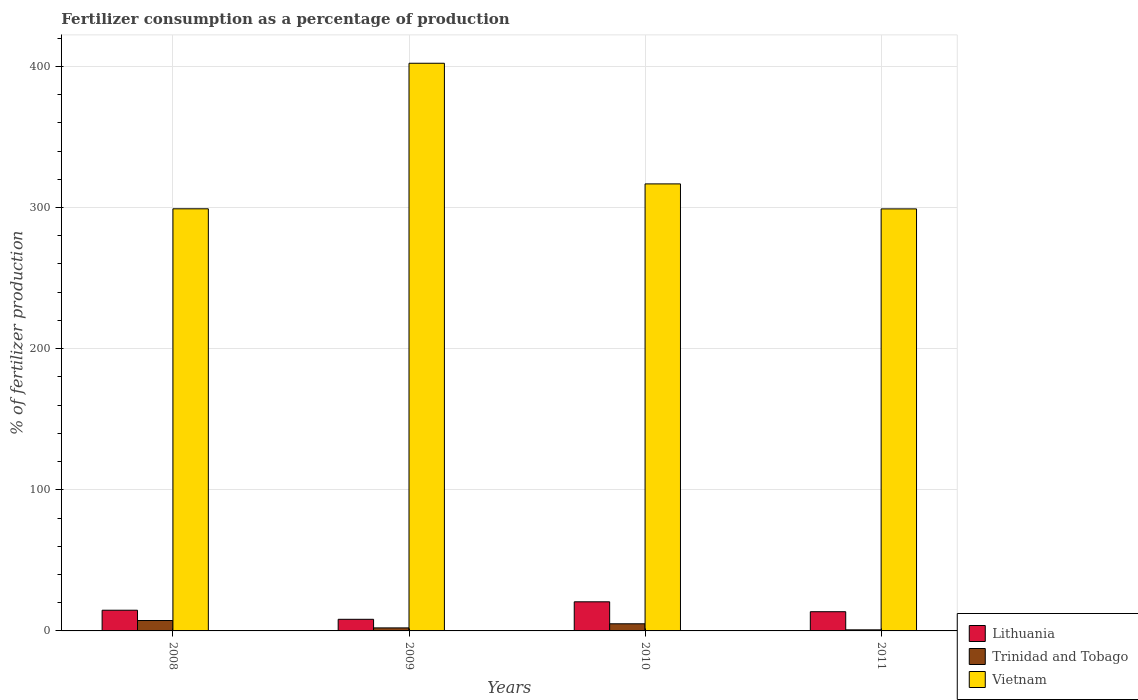How many groups of bars are there?
Offer a very short reply. 4. Are the number of bars per tick equal to the number of legend labels?
Offer a very short reply. Yes. How many bars are there on the 3rd tick from the right?
Your answer should be compact. 3. In how many cases, is the number of bars for a given year not equal to the number of legend labels?
Your response must be concise. 0. What is the percentage of fertilizers consumed in Vietnam in 2010?
Provide a succinct answer. 316.74. Across all years, what is the maximum percentage of fertilizers consumed in Lithuania?
Keep it short and to the point. 20.63. Across all years, what is the minimum percentage of fertilizers consumed in Trinidad and Tobago?
Your answer should be compact. 0.76. In which year was the percentage of fertilizers consumed in Trinidad and Tobago maximum?
Ensure brevity in your answer.  2008. In which year was the percentage of fertilizers consumed in Vietnam minimum?
Give a very brief answer. 2011. What is the total percentage of fertilizers consumed in Lithuania in the graph?
Offer a terse response. 57.13. What is the difference between the percentage of fertilizers consumed in Lithuania in 2008 and that in 2011?
Your response must be concise. 1.05. What is the difference between the percentage of fertilizers consumed in Vietnam in 2010 and the percentage of fertilizers consumed in Lithuania in 2009?
Your answer should be very brief. 308.5. What is the average percentage of fertilizers consumed in Lithuania per year?
Ensure brevity in your answer.  14.28. In the year 2010, what is the difference between the percentage of fertilizers consumed in Trinidad and Tobago and percentage of fertilizers consumed in Vietnam?
Provide a short and direct response. -311.68. What is the ratio of the percentage of fertilizers consumed in Trinidad and Tobago in 2010 to that in 2011?
Offer a very short reply. 6.65. What is the difference between the highest and the second highest percentage of fertilizers consumed in Vietnam?
Your answer should be compact. 85.48. What is the difference between the highest and the lowest percentage of fertilizers consumed in Vietnam?
Your answer should be compact. 103.2. What does the 2nd bar from the left in 2008 represents?
Ensure brevity in your answer.  Trinidad and Tobago. What does the 2nd bar from the right in 2009 represents?
Your answer should be compact. Trinidad and Tobago. Are all the bars in the graph horizontal?
Offer a very short reply. No. How many years are there in the graph?
Provide a succinct answer. 4. Does the graph contain grids?
Keep it short and to the point. Yes. Where does the legend appear in the graph?
Make the answer very short. Bottom right. How are the legend labels stacked?
Give a very brief answer. Vertical. What is the title of the graph?
Offer a very short reply. Fertilizer consumption as a percentage of production. What is the label or title of the X-axis?
Ensure brevity in your answer.  Years. What is the label or title of the Y-axis?
Give a very brief answer. % of fertilizer production. What is the % of fertilizer production in Lithuania in 2008?
Your answer should be compact. 14.66. What is the % of fertilizer production in Trinidad and Tobago in 2008?
Provide a short and direct response. 7.37. What is the % of fertilizer production in Vietnam in 2008?
Give a very brief answer. 299.09. What is the % of fertilizer production in Lithuania in 2009?
Give a very brief answer. 8.24. What is the % of fertilizer production in Trinidad and Tobago in 2009?
Your response must be concise. 2.14. What is the % of fertilizer production in Vietnam in 2009?
Ensure brevity in your answer.  402.22. What is the % of fertilizer production in Lithuania in 2010?
Make the answer very short. 20.63. What is the % of fertilizer production of Trinidad and Tobago in 2010?
Your response must be concise. 5.06. What is the % of fertilizer production of Vietnam in 2010?
Your answer should be very brief. 316.74. What is the % of fertilizer production in Lithuania in 2011?
Your answer should be compact. 13.61. What is the % of fertilizer production of Trinidad and Tobago in 2011?
Provide a succinct answer. 0.76. What is the % of fertilizer production in Vietnam in 2011?
Make the answer very short. 299.02. Across all years, what is the maximum % of fertilizer production of Lithuania?
Make the answer very short. 20.63. Across all years, what is the maximum % of fertilizer production of Trinidad and Tobago?
Your answer should be compact. 7.37. Across all years, what is the maximum % of fertilizer production in Vietnam?
Your answer should be very brief. 402.22. Across all years, what is the minimum % of fertilizer production of Lithuania?
Offer a very short reply. 8.24. Across all years, what is the minimum % of fertilizer production of Trinidad and Tobago?
Offer a very short reply. 0.76. Across all years, what is the minimum % of fertilizer production in Vietnam?
Make the answer very short. 299.02. What is the total % of fertilizer production in Lithuania in the graph?
Offer a terse response. 57.13. What is the total % of fertilizer production of Trinidad and Tobago in the graph?
Your answer should be compact. 15.33. What is the total % of fertilizer production in Vietnam in the graph?
Provide a succinct answer. 1317.06. What is the difference between the % of fertilizer production in Lithuania in 2008 and that in 2009?
Your answer should be very brief. 6.43. What is the difference between the % of fertilizer production of Trinidad and Tobago in 2008 and that in 2009?
Provide a succinct answer. 5.23. What is the difference between the % of fertilizer production of Vietnam in 2008 and that in 2009?
Provide a short and direct response. -103.13. What is the difference between the % of fertilizer production of Lithuania in 2008 and that in 2010?
Keep it short and to the point. -5.97. What is the difference between the % of fertilizer production in Trinidad and Tobago in 2008 and that in 2010?
Your answer should be very brief. 2.31. What is the difference between the % of fertilizer production in Vietnam in 2008 and that in 2010?
Offer a terse response. -17.65. What is the difference between the % of fertilizer production of Lithuania in 2008 and that in 2011?
Provide a succinct answer. 1.05. What is the difference between the % of fertilizer production of Trinidad and Tobago in 2008 and that in 2011?
Your answer should be compact. 6.61. What is the difference between the % of fertilizer production of Vietnam in 2008 and that in 2011?
Give a very brief answer. 0.07. What is the difference between the % of fertilizer production of Lithuania in 2009 and that in 2010?
Provide a short and direct response. -12.39. What is the difference between the % of fertilizer production of Trinidad and Tobago in 2009 and that in 2010?
Your answer should be compact. -2.91. What is the difference between the % of fertilizer production in Vietnam in 2009 and that in 2010?
Ensure brevity in your answer.  85.48. What is the difference between the % of fertilizer production of Lithuania in 2009 and that in 2011?
Provide a short and direct response. -5.37. What is the difference between the % of fertilizer production of Trinidad and Tobago in 2009 and that in 2011?
Offer a very short reply. 1.38. What is the difference between the % of fertilizer production in Vietnam in 2009 and that in 2011?
Give a very brief answer. 103.2. What is the difference between the % of fertilizer production of Lithuania in 2010 and that in 2011?
Offer a terse response. 7.02. What is the difference between the % of fertilizer production in Trinidad and Tobago in 2010 and that in 2011?
Provide a short and direct response. 4.3. What is the difference between the % of fertilizer production of Vietnam in 2010 and that in 2011?
Provide a succinct answer. 17.72. What is the difference between the % of fertilizer production in Lithuania in 2008 and the % of fertilizer production in Trinidad and Tobago in 2009?
Offer a terse response. 12.52. What is the difference between the % of fertilizer production in Lithuania in 2008 and the % of fertilizer production in Vietnam in 2009?
Offer a terse response. -387.55. What is the difference between the % of fertilizer production of Trinidad and Tobago in 2008 and the % of fertilizer production of Vietnam in 2009?
Offer a terse response. -394.84. What is the difference between the % of fertilizer production of Lithuania in 2008 and the % of fertilizer production of Trinidad and Tobago in 2010?
Ensure brevity in your answer.  9.6. What is the difference between the % of fertilizer production of Lithuania in 2008 and the % of fertilizer production of Vietnam in 2010?
Make the answer very short. -302.08. What is the difference between the % of fertilizer production of Trinidad and Tobago in 2008 and the % of fertilizer production of Vietnam in 2010?
Your answer should be compact. -309.37. What is the difference between the % of fertilizer production of Lithuania in 2008 and the % of fertilizer production of Trinidad and Tobago in 2011?
Your answer should be compact. 13.9. What is the difference between the % of fertilizer production of Lithuania in 2008 and the % of fertilizer production of Vietnam in 2011?
Your response must be concise. -284.36. What is the difference between the % of fertilizer production of Trinidad and Tobago in 2008 and the % of fertilizer production of Vietnam in 2011?
Keep it short and to the point. -291.65. What is the difference between the % of fertilizer production in Lithuania in 2009 and the % of fertilizer production in Trinidad and Tobago in 2010?
Your answer should be compact. 3.18. What is the difference between the % of fertilizer production in Lithuania in 2009 and the % of fertilizer production in Vietnam in 2010?
Provide a succinct answer. -308.5. What is the difference between the % of fertilizer production in Trinidad and Tobago in 2009 and the % of fertilizer production in Vietnam in 2010?
Make the answer very short. -314.59. What is the difference between the % of fertilizer production in Lithuania in 2009 and the % of fertilizer production in Trinidad and Tobago in 2011?
Provide a succinct answer. 7.47. What is the difference between the % of fertilizer production in Lithuania in 2009 and the % of fertilizer production in Vietnam in 2011?
Give a very brief answer. -290.78. What is the difference between the % of fertilizer production in Trinidad and Tobago in 2009 and the % of fertilizer production in Vietnam in 2011?
Ensure brevity in your answer.  -296.87. What is the difference between the % of fertilizer production of Lithuania in 2010 and the % of fertilizer production of Trinidad and Tobago in 2011?
Provide a short and direct response. 19.87. What is the difference between the % of fertilizer production of Lithuania in 2010 and the % of fertilizer production of Vietnam in 2011?
Offer a very short reply. -278.39. What is the difference between the % of fertilizer production in Trinidad and Tobago in 2010 and the % of fertilizer production in Vietnam in 2011?
Ensure brevity in your answer.  -293.96. What is the average % of fertilizer production of Lithuania per year?
Your answer should be compact. 14.28. What is the average % of fertilizer production of Trinidad and Tobago per year?
Provide a succinct answer. 3.83. What is the average % of fertilizer production of Vietnam per year?
Provide a short and direct response. 329.26. In the year 2008, what is the difference between the % of fertilizer production in Lithuania and % of fertilizer production in Trinidad and Tobago?
Offer a very short reply. 7.29. In the year 2008, what is the difference between the % of fertilizer production of Lithuania and % of fertilizer production of Vietnam?
Keep it short and to the point. -284.43. In the year 2008, what is the difference between the % of fertilizer production in Trinidad and Tobago and % of fertilizer production in Vietnam?
Your answer should be compact. -291.72. In the year 2009, what is the difference between the % of fertilizer production of Lithuania and % of fertilizer production of Trinidad and Tobago?
Ensure brevity in your answer.  6.09. In the year 2009, what is the difference between the % of fertilizer production in Lithuania and % of fertilizer production in Vietnam?
Your answer should be very brief. -393.98. In the year 2009, what is the difference between the % of fertilizer production of Trinidad and Tobago and % of fertilizer production of Vietnam?
Your answer should be compact. -400.07. In the year 2010, what is the difference between the % of fertilizer production in Lithuania and % of fertilizer production in Trinidad and Tobago?
Give a very brief answer. 15.57. In the year 2010, what is the difference between the % of fertilizer production of Lithuania and % of fertilizer production of Vietnam?
Make the answer very short. -296.11. In the year 2010, what is the difference between the % of fertilizer production of Trinidad and Tobago and % of fertilizer production of Vietnam?
Ensure brevity in your answer.  -311.68. In the year 2011, what is the difference between the % of fertilizer production of Lithuania and % of fertilizer production of Trinidad and Tobago?
Your answer should be compact. 12.85. In the year 2011, what is the difference between the % of fertilizer production in Lithuania and % of fertilizer production in Vietnam?
Offer a very short reply. -285.41. In the year 2011, what is the difference between the % of fertilizer production in Trinidad and Tobago and % of fertilizer production in Vietnam?
Your answer should be compact. -298.26. What is the ratio of the % of fertilizer production in Lithuania in 2008 to that in 2009?
Provide a succinct answer. 1.78. What is the ratio of the % of fertilizer production of Trinidad and Tobago in 2008 to that in 2009?
Offer a very short reply. 3.44. What is the ratio of the % of fertilizer production of Vietnam in 2008 to that in 2009?
Your response must be concise. 0.74. What is the ratio of the % of fertilizer production in Lithuania in 2008 to that in 2010?
Your response must be concise. 0.71. What is the ratio of the % of fertilizer production in Trinidad and Tobago in 2008 to that in 2010?
Your answer should be very brief. 1.46. What is the ratio of the % of fertilizer production of Vietnam in 2008 to that in 2010?
Your answer should be very brief. 0.94. What is the ratio of the % of fertilizer production of Lithuania in 2008 to that in 2011?
Keep it short and to the point. 1.08. What is the ratio of the % of fertilizer production of Trinidad and Tobago in 2008 to that in 2011?
Give a very brief answer. 9.68. What is the ratio of the % of fertilizer production in Lithuania in 2009 to that in 2010?
Ensure brevity in your answer.  0.4. What is the ratio of the % of fertilizer production in Trinidad and Tobago in 2009 to that in 2010?
Provide a succinct answer. 0.42. What is the ratio of the % of fertilizer production of Vietnam in 2009 to that in 2010?
Your answer should be very brief. 1.27. What is the ratio of the % of fertilizer production of Lithuania in 2009 to that in 2011?
Provide a succinct answer. 0.61. What is the ratio of the % of fertilizer production in Trinidad and Tobago in 2009 to that in 2011?
Provide a succinct answer. 2.82. What is the ratio of the % of fertilizer production of Vietnam in 2009 to that in 2011?
Keep it short and to the point. 1.35. What is the ratio of the % of fertilizer production of Lithuania in 2010 to that in 2011?
Offer a very short reply. 1.52. What is the ratio of the % of fertilizer production of Trinidad and Tobago in 2010 to that in 2011?
Provide a short and direct response. 6.65. What is the ratio of the % of fertilizer production of Vietnam in 2010 to that in 2011?
Your response must be concise. 1.06. What is the difference between the highest and the second highest % of fertilizer production in Lithuania?
Provide a short and direct response. 5.97. What is the difference between the highest and the second highest % of fertilizer production in Trinidad and Tobago?
Provide a succinct answer. 2.31. What is the difference between the highest and the second highest % of fertilizer production of Vietnam?
Offer a very short reply. 85.48. What is the difference between the highest and the lowest % of fertilizer production in Lithuania?
Make the answer very short. 12.39. What is the difference between the highest and the lowest % of fertilizer production in Trinidad and Tobago?
Give a very brief answer. 6.61. What is the difference between the highest and the lowest % of fertilizer production of Vietnam?
Make the answer very short. 103.2. 